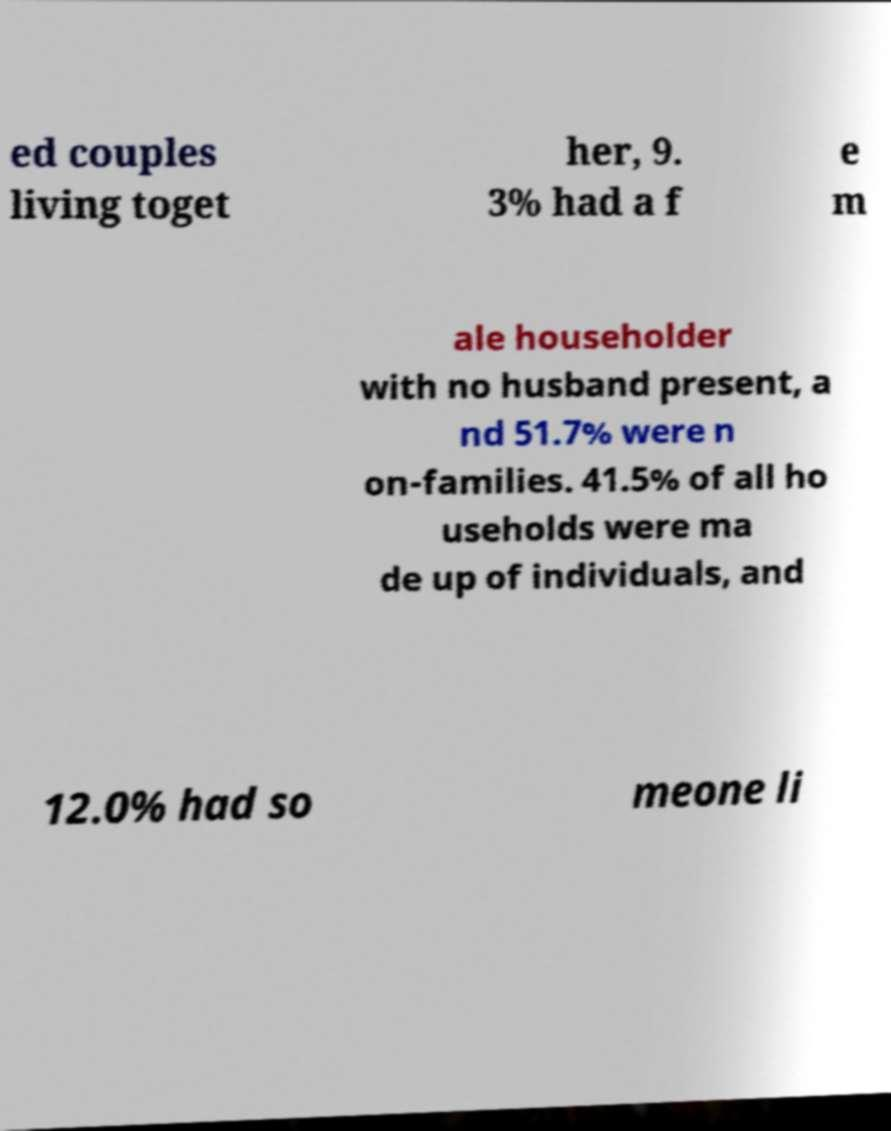Please read and relay the text visible in this image. What does it say? ed couples living toget her, 9. 3% had a f e m ale householder with no husband present, a nd 51.7% were n on-families. 41.5% of all ho useholds were ma de up of individuals, and 12.0% had so meone li 